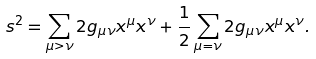Convert formula to latex. <formula><loc_0><loc_0><loc_500><loc_500>s ^ { 2 } = \sum _ { { \mu } > { \nu } } 2 g _ { \mu \nu } x ^ { \mu } x ^ { \nu } + \frac { 1 } { 2 } \sum _ { { \mu } = { \nu } } 2 g _ { \mu \nu } x ^ { \mu } x ^ { \nu } .</formula> 